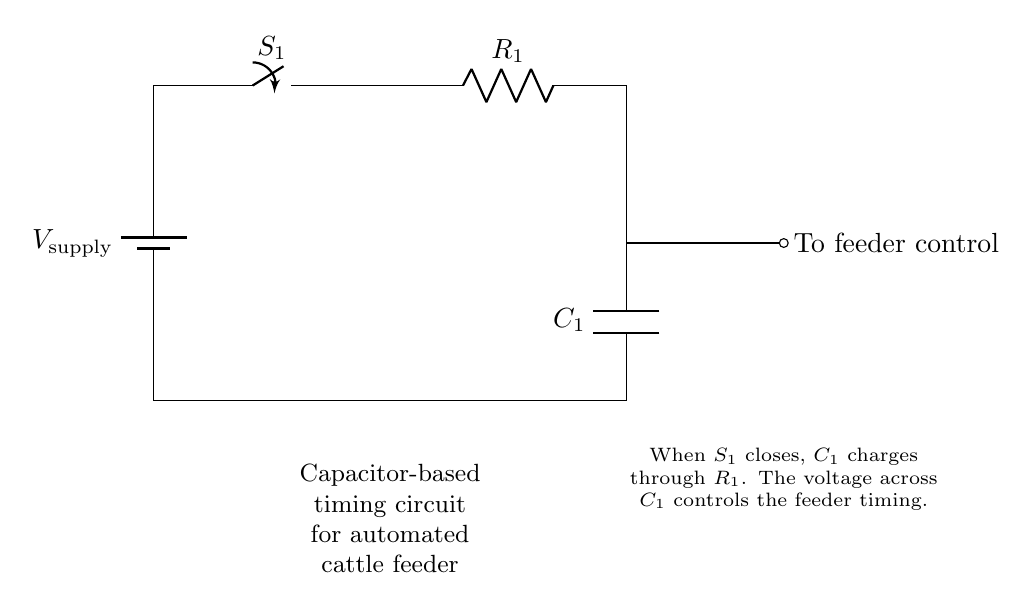What type of circuit is this? This circuit is a capacitor-based timing circuit, identified by the presence of a resistor and capacitor in series, where the capacitor controls the timing based on its charge.
Answer: Capacitor-based timing circuit What component controls the timing? The timing in the circuit is controlled by the capacitor, as its charging and discharging times directly influence how long the feeder operates after the switch is closed.
Answer: Capacitor What is the role of the switch? The switch acts as a control mechanism to start or stop the capacitor charging process, thereby determining when the feeder begins its timing cycle.
Answer: Control mechanism How is the capacitor charged? The capacitor charges through the resistor when the switch is closed, allowing current to flow into the capacitor until it reaches a certain voltage level.
Answer: Through the resistor What happens when the switch is closed? When the switch is closed, the capacitor begins charging, and the voltage across it increases, eventually reaching a level that activates the feeder control.
Answer: Capacitor charges and activates feeder What is the effect of the resistor value on timing? The resistor value affects the time it takes for the capacitor to charge; a higher resistor value means a slower charge, resulting in longer timing for the feeder, while a lower value means a quicker charge and shorter timing.
Answer: Affects charging time What determines the voltage across the capacitor? The voltage across the capacitor is determined by the supply voltage and the rate at which it charges through the resistor, which controls the timing mechanism in the circuit.
Answer: Supply voltage and charging rate 